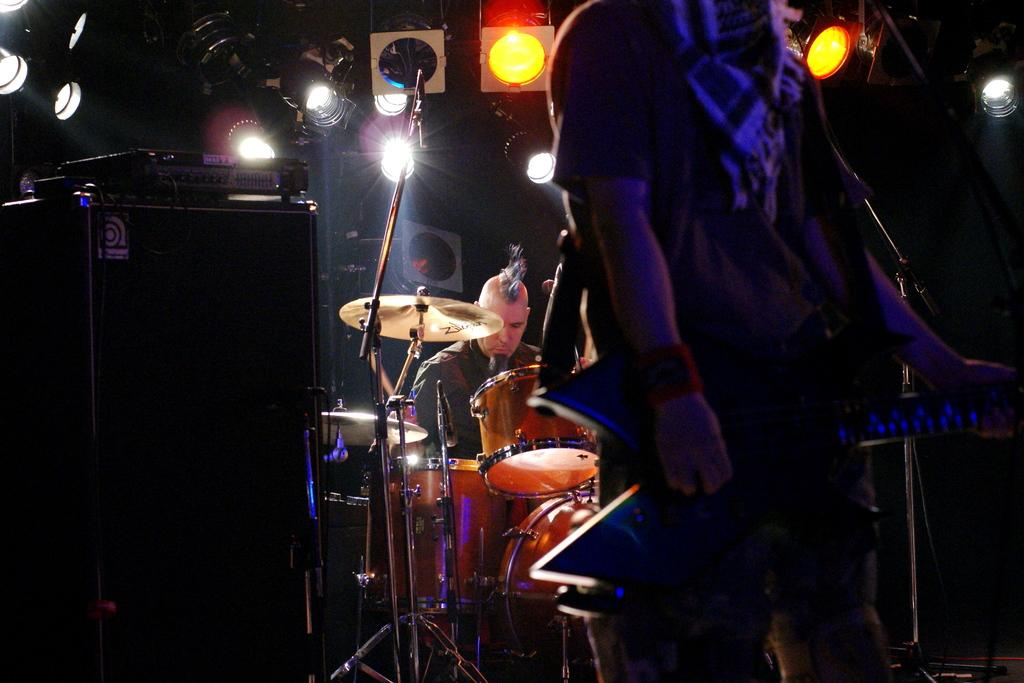How many men are present in the image? There are two men present in the image, one standing and one seated. What is the seated man doing in the image? The seated man is playing drums. What object is visible that might be used for amplifying sound? There is a microphone visible in the image. What time of day is it in the image, according to the theory of morning? The facts provided do not mention any time of day or any theory related to morning. Can you see any ants in the image? There are no ants visible in the image. 